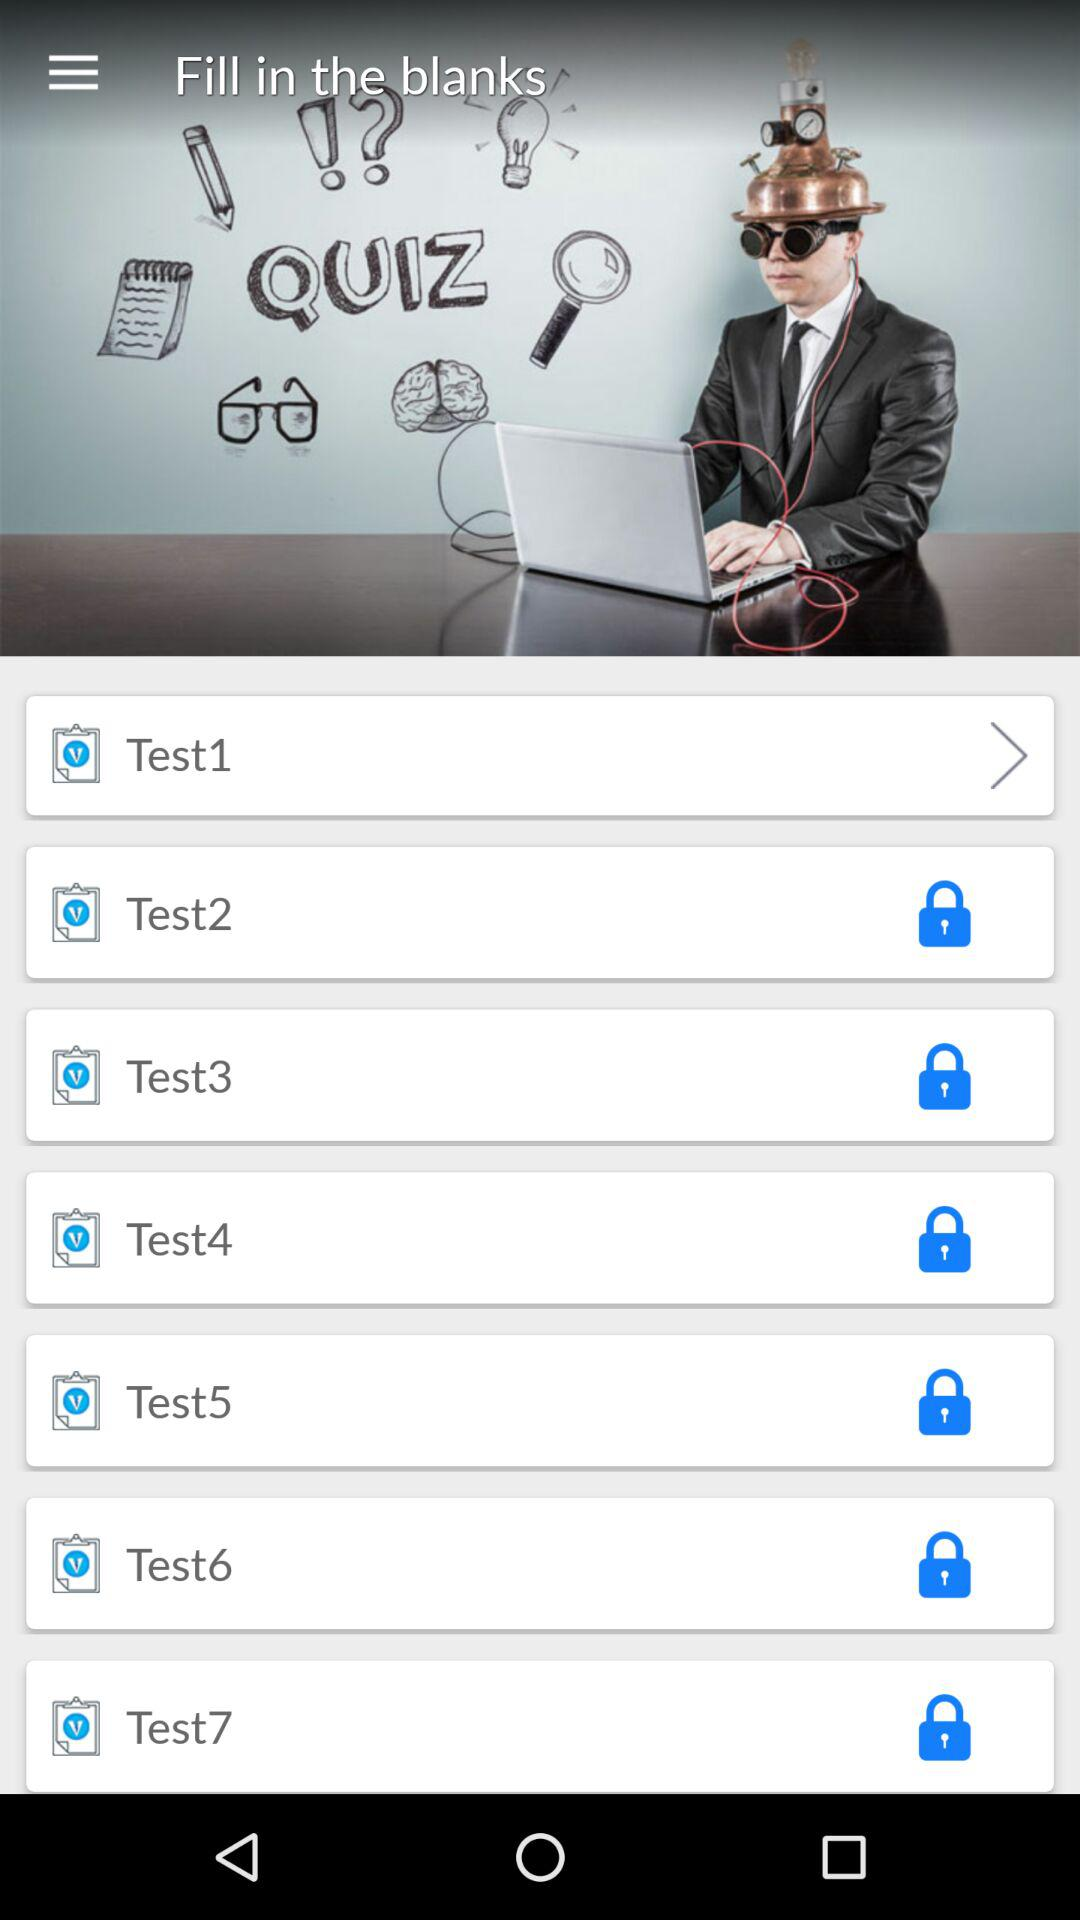Which test is currently unlocked? The test that is currently unlocked is "Test1". 